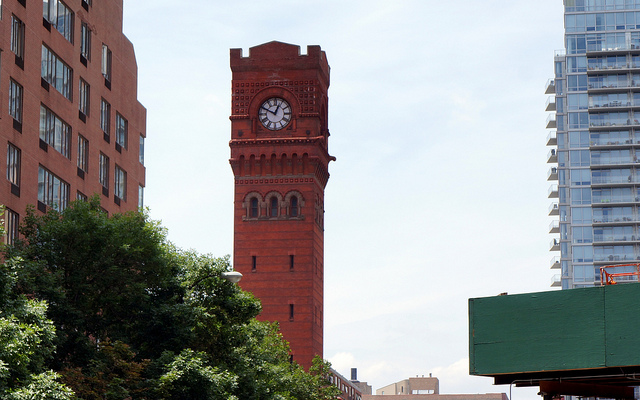Is the time correct? Without a reference time, it is impossible to confirm the accuracy of the clock's time; however, it appears to be functional. 